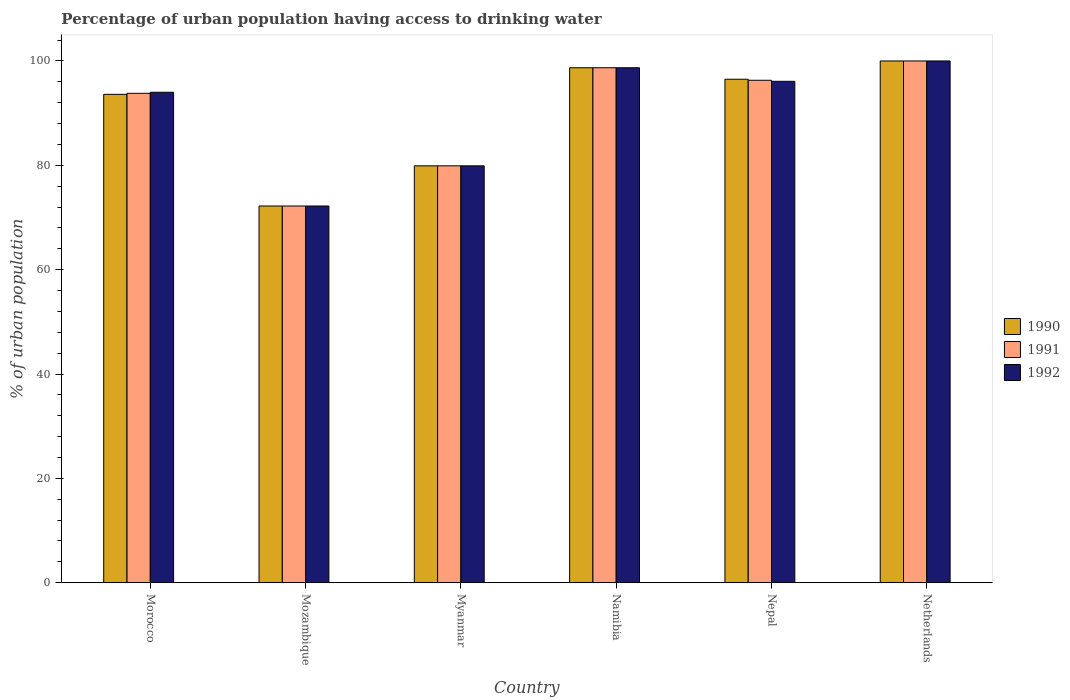How many different coloured bars are there?
Make the answer very short. 3. Are the number of bars per tick equal to the number of legend labels?
Offer a terse response. Yes. In how many cases, is the number of bars for a given country not equal to the number of legend labels?
Your response must be concise. 0. What is the percentage of urban population having access to drinking water in 1990 in Mozambique?
Provide a succinct answer. 72.2. Across all countries, what is the minimum percentage of urban population having access to drinking water in 1991?
Ensure brevity in your answer.  72.2. In which country was the percentage of urban population having access to drinking water in 1990 maximum?
Your response must be concise. Netherlands. In which country was the percentage of urban population having access to drinking water in 1991 minimum?
Give a very brief answer. Mozambique. What is the total percentage of urban population having access to drinking water in 1992 in the graph?
Your response must be concise. 540.9. What is the difference between the percentage of urban population having access to drinking water in 1990 in Myanmar and the percentage of urban population having access to drinking water in 1991 in Mozambique?
Your response must be concise. 7.7. What is the average percentage of urban population having access to drinking water in 1991 per country?
Provide a short and direct response. 90.15. What is the difference between the percentage of urban population having access to drinking water of/in 1991 and percentage of urban population having access to drinking water of/in 1990 in Namibia?
Offer a very short reply. 0. In how many countries, is the percentage of urban population having access to drinking water in 1992 greater than 48 %?
Offer a very short reply. 6. What is the ratio of the percentage of urban population having access to drinking water in 1991 in Morocco to that in Mozambique?
Provide a succinct answer. 1.3. Is the difference between the percentage of urban population having access to drinking water in 1991 in Morocco and Netherlands greater than the difference between the percentage of urban population having access to drinking water in 1990 in Morocco and Netherlands?
Provide a short and direct response. Yes. What is the difference between the highest and the second highest percentage of urban population having access to drinking water in 1990?
Offer a terse response. -2.2. What is the difference between the highest and the lowest percentage of urban population having access to drinking water in 1991?
Ensure brevity in your answer.  27.8. In how many countries, is the percentage of urban population having access to drinking water in 1991 greater than the average percentage of urban population having access to drinking water in 1991 taken over all countries?
Provide a succinct answer. 4. What does the 2nd bar from the left in Nepal represents?
Your answer should be compact. 1991. What does the 3rd bar from the right in Myanmar represents?
Offer a very short reply. 1990. Are all the bars in the graph horizontal?
Keep it short and to the point. No. How many countries are there in the graph?
Offer a very short reply. 6. What is the difference between two consecutive major ticks on the Y-axis?
Ensure brevity in your answer.  20. Where does the legend appear in the graph?
Make the answer very short. Center right. How many legend labels are there?
Offer a terse response. 3. How are the legend labels stacked?
Provide a short and direct response. Vertical. What is the title of the graph?
Provide a short and direct response. Percentage of urban population having access to drinking water. Does "1991" appear as one of the legend labels in the graph?
Give a very brief answer. Yes. What is the label or title of the X-axis?
Your answer should be compact. Country. What is the label or title of the Y-axis?
Your response must be concise. % of urban population. What is the % of urban population of 1990 in Morocco?
Provide a short and direct response. 93.6. What is the % of urban population of 1991 in Morocco?
Provide a short and direct response. 93.8. What is the % of urban population of 1992 in Morocco?
Your answer should be compact. 94. What is the % of urban population in 1990 in Mozambique?
Give a very brief answer. 72.2. What is the % of urban population in 1991 in Mozambique?
Your answer should be very brief. 72.2. What is the % of urban population of 1992 in Mozambique?
Ensure brevity in your answer.  72.2. What is the % of urban population in 1990 in Myanmar?
Give a very brief answer. 79.9. What is the % of urban population of 1991 in Myanmar?
Provide a succinct answer. 79.9. What is the % of urban population in 1992 in Myanmar?
Offer a terse response. 79.9. What is the % of urban population of 1990 in Namibia?
Your answer should be very brief. 98.7. What is the % of urban population in 1991 in Namibia?
Ensure brevity in your answer.  98.7. What is the % of urban population in 1992 in Namibia?
Keep it short and to the point. 98.7. What is the % of urban population of 1990 in Nepal?
Offer a very short reply. 96.5. What is the % of urban population in 1991 in Nepal?
Provide a succinct answer. 96.3. What is the % of urban population in 1992 in Nepal?
Ensure brevity in your answer.  96.1. What is the % of urban population in 1991 in Netherlands?
Your response must be concise. 100. What is the % of urban population in 1992 in Netherlands?
Offer a terse response. 100. Across all countries, what is the maximum % of urban population in 1991?
Your response must be concise. 100. Across all countries, what is the maximum % of urban population of 1992?
Give a very brief answer. 100. Across all countries, what is the minimum % of urban population in 1990?
Provide a succinct answer. 72.2. Across all countries, what is the minimum % of urban population in 1991?
Keep it short and to the point. 72.2. Across all countries, what is the minimum % of urban population in 1992?
Your answer should be very brief. 72.2. What is the total % of urban population of 1990 in the graph?
Provide a short and direct response. 540.9. What is the total % of urban population of 1991 in the graph?
Provide a short and direct response. 540.9. What is the total % of urban population in 1992 in the graph?
Provide a succinct answer. 540.9. What is the difference between the % of urban population in 1990 in Morocco and that in Mozambique?
Offer a very short reply. 21.4. What is the difference between the % of urban population of 1991 in Morocco and that in Mozambique?
Give a very brief answer. 21.6. What is the difference between the % of urban population of 1992 in Morocco and that in Mozambique?
Your answer should be very brief. 21.8. What is the difference between the % of urban population in 1990 in Morocco and that in Myanmar?
Provide a succinct answer. 13.7. What is the difference between the % of urban population in 1991 in Morocco and that in Myanmar?
Offer a very short reply. 13.9. What is the difference between the % of urban population of 1990 in Morocco and that in Namibia?
Ensure brevity in your answer.  -5.1. What is the difference between the % of urban population of 1992 in Morocco and that in Namibia?
Offer a terse response. -4.7. What is the difference between the % of urban population in 1990 in Morocco and that in Nepal?
Provide a succinct answer. -2.9. What is the difference between the % of urban population in 1991 in Morocco and that in Nepal?
Your answer should be very brief. -2.5. What is the difference between the % of urban population of 1992 in Morocco and that in Netherlands?
Make the answer very short. -6. What is the difference between the % of urban population in 1990 in Mozambique and that in Myanmar?
Provide a succinct answer. -7.7. What is the difference between the % of urban population in 1990 in Mozambique and that in Namibia?
Your answer should be compact. -26.5. What is the difference between the % of urban population in 1991 in Mozambique and that in Namibia?
Your response must be concise. -26.5. What is the difference between the % of urban population of 1992 in Mozambique and that in Namibia?
Provide a succinct answer. -26.5. What is the difference between the % of urban population in 1990 in Mozambique and that in Nepal?
Ensure brevity in your answer.  -24.3. What is the difference between the % of urban population of 1991 in Mozambique and that in Nepal?
Provide a succinct answer. -24.1. What is the difference between the % of urban population in 1992 in Mozambique and that in Nepal?
Keep it short and to the point. -23.9. What is the difference between the % of urban population in 1990 in Mozambique and that in Netherlands?
Your answer should be compact. -27.8. What is the difference between the % of urban population in 1991 in Mozambique and that in Netherlands?
Your answer should be very brief. -27.8. What is the difference between the % of urban population of 1992 in Mozambique and that in Netherlands?
Ensure brevity in your answer.  -27.8. What is the difference between the % of urban population of 1990 in Myanmar and that in Namibia?
Provide a short and direct response. -18.8. What is the difference between the % of urban population in 1991 in Myanmar and that in Namibia?
Make the answer very short. -18.8. What is the difference between the % of urban population in 1992 in Myanmar and that in Namibia?
Your response must be concise. -18.8. What is the difference between the % of urban population in 1990 in Myanmar and that in Nepal?
Give a very brief answer. -16.6. What is the difference between the % of urban population of 1991 in Myanmar and that in Nepal?
Your response must be concise. -16.4. What is the difference between the % of urban population in 1992 in Myanmar and that in Nepal?
Ensure brevity in your answer.  -16.2. What is the difference between the % of urban population in 1990 in Myanmar and that in Netherlands?
Offer a very short reply. -20.1. What is the difference between the % of urban population in 1991 in Myanmar and that in Netherlands?
Your answer should be very brief. -20.1. What is the difference between the % of urban population of 1992 in Myanmar and that in Netherlands?
Keep it short and to the point. -20.1. What is the difference between the % of urban population in 1990 in Namibia and that in Nepal?
Offer a very short reply. 2.2. What is the difference between the % of urban population in 1991 in Namibia and that in Nepal?
Provide a short and direct response. 2.4. What is the difference between the % of urban population of 1992 in Namibia and that in Nepal?
Your answer should be compact. 2.6. What is the difference between the % of urban population of 1992 in Namibia and that in Netherlands?
Your answer should be very brief. -1.3. What is the difference between the % of urban population in 1990 in Nepal and that in Netherlands?
Offer a terse response. -3.5. What is the difference between the % of urban population in 1991 in Nepal and that in Netherlands?
Keep it short and to the point. -3.7. What is the difference between the % of urban population of 1992 in Nepal and that in Netherlands?
Make the answer very short. -3.9. What is the difference between the % of urban population of 1990 in Morocco and the % of urban population of 1991 in Mozambique?
Your response must be concise. 21.4. What is the difference between the % of urban population in 1990 in Morocco and the % of urban population in 1992 in Mozambique?
Your answer should be very brief. 21.4. What is the difference between the % of urban population of 1991 in Morocco and the % of urban population of 1992 in Mozambique?
Offer a very short reply. 21.6. What is the difference between the % of urban population in 1991 in Morocco and the % of urban population in 1992 in Myanmar?
Your answer should be very brief. 13.9. What is the difference between the % of urban population of 1991 in Morocco and the % of urban population of 1992 in Namibia?
Make the answer very short. -4.9. What is the difference between the % of urban population in 1990 in Morocco and the % of urban population in 1992 in Nepal?
Make the answer very short. -2.5. What is the difference between the % of urban population in 1991 in Morocco and the % of urban population in 1992 in Netherlands?
Make the answer very short. -6.2. What is the difference between the % of urban population of 1990 in Mozambique and the % of urban population of 1991 in Namibia?
Offer a very short reply. -26.5. What is the difference between the % of urban population of 1990 in Mozambique and the % of urban population of 1992 in Namibia?
Keep it short and to the point. -26.5. What is the difference between the % of urban population of 1991 in Mozambique and the % of urban population of 1992 in Namibia?
Your answer should be very brief. -26.5. What is the difference between the % of urban population of 1990 in Mozambique and the % of urban population of 1991 in Nepal?
Keep it short and to the point. -24.1. What is the difference between the % of urban population of 1990 in Mozambique and the % of urban population of 1992 in Nepal?
Your response must be concise. -23.9. What is the difference between the % of urban population of 1991 in Mozambique and the % of urban population of 1992 in Nepal?
Your answer should be very brief. -23.9. What is the difference between the % of urban population of 1990 in Mozambique and the % of urban population of 1991 in Netherlands?
Give a very brief answer. -27.8. What is the difference between the % of urban population in 1990 in Mozambique and the % of urban population in 1992 in Netherlands?
Provide a succinct answer. -27.8. What is the difference between the % of urban population in 1991 in Mozambique and the % of urban population in 1992 in Netherlands?
Provide a succinct answer. -27.8. What is the difference between the % of urban population of 1990 in Myanmar and the % of urban population of 1991 in Namibia?
Your response must be concise. -18.8. What is the difference between the % of urban population of 1990 in Myanmar and the % of urban population of 1992 in Namibia?
Your answer should be very brief. -18.8. What is the difference between the % of urban population in 1991 in Myanmar and the % of urban population in 1992 in Namibia?
Provide a succinct answer. -18.8. What is the difference between the % of urban population in 1990 in Myanmar and the % of urban population in 1991 in Nepal?
Give a very brief answer. -16.4. What is the difference between the % of urban population in 1990 in Myanmar and the % of urban population in 1992 in Nepal?
Provide a succinct answer. -16.2. What is the difference between the % of urban population of 1991 in Myanmar and the % of urban population of 1992 in Nepal?
Your answer should be very brief. -16.2. What is the difference between the % of urban population in 1990 in Myanmar and the % of urban population in 1991 in Netherlands?
Make the answer very short. -20.1. What is the difference between the % of urban population in 1990 in Myanmar and the % of urban population in 1992 in Netherlands?
Your answer should be compact. -20.1. What is the difference between the % of urban population of 1991 in Myanmar and the % of urban population of 1992 in Netherlands?
Your answer should be very brief. -20.1. What is the difference between the % of urban population in 1990 in Namibia and the % of urban population in 1991 in Nepal?
Your answer should be very brief. 2.4. What is the difference between the % of urban population in 1991 in Namibia and the % of urban population in 1992 in Netherlands?
Give a very brief answer. -1.3. What is the difference between the % of urban population in 1990 in Nepal and the % of urban population in 1992 in Netherlands?
Provide a short and direct response. -3.5. What is the average % of urban population in 1990 per country?
Provide a short and direct response. 90.15. What is the average % of urban population of 1991 per country?
Keep it short and to the point. 90.15. What is the average % of urban population of 1992 per country?
Keep it short and to the point. 90.15. What is the difference between the % of urban population in 1990 and % of urban population in 1991 in Morocco?
Provide a succinct answer. -0.2. What is the difference between the % of urban population of 1990 and % of urban population of 1992 in Morocco?
Your response must be concise. -0.4. What is the difference between the % of urban population of 1990 and % of urban population of 1992 in Myanmar?
Make the answer very short. 0. What is the difference between the % of urban population of 1991 and % of urban population of 1992 in Namibia?
Your answer should be compact. 0. What is the difference between the % of urban population of 1990 and % of urban population of 1992 in Nepal?
Give a very brief answer. 0.4. What is the difference between the % of urban population in 1990 and % of urban population in 1991 in Netherlands?
Ensure brevity in your answer.  0. What is the difference between the % of urban population in 1991 and % of urban population in 1992 in Netherlands?
Ensure brevity in your answer.  0. What is the ratio of the % of urban population in 1990 in Morocco to that in Mozambique?
Provide a short and direct response. 1.3. What is the ratio of the % of urban population of 1991 in Morocco to that in Mozambique?
Your answer should be compact. 1.3. What is the ratio of the % of urban population in 1992 in Morocco to that in Mozambique?
Offer a terse response. 1.3. What is the ratio of the % of urban population in 1990 in Morocco to that in Myanmar?
Provide a succinct answer. 1.17. What is the ratio of the % of urban population of 1991 in Morocco to that in Myanmar?
Make the answer very short. 1.17. What is the ratio of the % of urban population in 1992 in Morocco to that in Myanmar?
Your answer should be compact. 1.18. What is the ratio of the % of urban population in 1990 in Morocco to that in Namibia?
Offer a very short reply. 0.95. What is the ratio of the % of urban population of 1991 in Morocco to that in Namibia?
Your answer should be very brief. 0.95. What is the ratio of the % of urban population of 1990 in Morocco to that in Nepal?
Offer a terse response. 0.97. What is the ratio of the % of urban population in 1992 in Morocco to that in Nepal?
Your response must be concise. 0.98. What is the ratio of the % of urban population of 1990 in Morocco to that in Netherlands?
Ensure brevity in your answer.  0.94. What is the ratio of the % of urban population in 1991 in Morocco to that in Netherlands?
Your answer should be very brief. 0.94. What is the ratio of the % of urban population in 1992 in Morocco to that in Netherlands?
Offer a terse response. 0.94. What is the ratio of the % of urban population in 1990 in Mozambique to that in Myanmar?
Ensure brevity in your answer.  0.9. What is the ratio of the % of urban population of 1991 in Mozambique to that in Myanmar?
Your answer should be very brief. 0.9. What is the ratio of the % of urban population in 1992 in Mozambique to that in Myanmar?
Your response must be concise. 0.9. What is the ratio of the % of urban population in 1990 in Mozambique to that in Namibia?
Your answer should be very brief. 0.73. What is the ratio of the % of urban population in 1991 in Mozambique to that in Namibia?
Ensure brevity in your answer.  0.73. What is the ratio of the % of urban population in 1992 in Mozambique to that in Namibia?
Your answer should be very brief. 0.73. What is the ratio of the % of urban population of 1990 in Mozambique to that in Nepal?
Your response must be concise. 0.75. What is the ratio of the % of urban population in 1991 in Mozambique to that in Nepal?
Provide a succinct answer. 0.75. What is the ratio of the % of urban population of 1992 in Mozambique to that in Nepal?
Give a very brief answer. 0.75. What is the ratio of the % of urban population of 1990 in Mozambique to that in Netherlands?
Ensure brevity in your answer.  0.72. What is the ratio of the % of urban population of 1991 in Mozambique to that in Netherlands?
Make the answer very short. 0.72. What is the ratio of the % of urban population of 1992 in Mozambique to that in Netherlands?
Keep it short and to the point. 0.72. What is the ratio of the % of urban population in 1990 in Myanmar to that in Namibia?
Your answer should be compact. 0.81. What is the ratio of the % of urban population of 1991 in Myanmar to that in Namibia?
Your answer should be very brief. 0.81. What is the ratio of the % of urban population in 1992 in Myanmar to that in Namibia?
Your answer should be very brief. 0.81. What is the ratio of the % of urban population of 1990 in Myanmar to that in Nepal?
Offer a very short reply. 0.83. What is the ratio of the % of urban population of 1991 in Myanmar to that in Nepal?
Your answer should be compact. 0.83. What is the ratio of the % of urban population of 1992 in Myanmar to that in Nepal?
Offer a very short reply. 0.83. What is the ratio of the % of urban population in 1990 in Myanmar to that in Netherlands?
Offer a terse response. 0.8. What is the ratio of the % of urban population in 1991 in Myanmar to that in Netherlands?
Offer a very short reply. 0.8. What is the ratio of the % of urban population of 1992 in Myanmar to that in Netherlands?
Your answer should be compact. 0.8. What is the ratio of the % of urban population in 1990 in Namibia to that in Nepal?
Give a very brief answer. 1.02. What is the ratio of the % of urban population in 1991 in Namibia to that in Nepal?
Your response must be concise. 1.02. What is the ratio of the % of urban population in 1992 in Namibia to that in Nepal?
Your answer should be compact. 1.03. What is the ratio of the % of urban population in 1991 in Namibia to that in Netherlands?
Offer a terse response. 0.99. What is the ratio of the % of urban population of 1992 in Namibia to that in Netherlands?
Keep it short and to the point. 0.99. What is the ratio of the % of urban population of 1990 in Nepal to that in Netherlands?
Provide a short and direct response. 0.96. What is the ratio of the % of urban population in 1992 in Nepal to that in Netherlands?
Make the answer very short. 0.96. What is the difference between the highest and the second highest % of urban population of 1990?
Make the answer very short. 1.3. What is the difference between the highest and the second highest % of urban population in 1991?
Keep it short and to the point. 1.3. What is the difference between the highest and the second highest % of urban population of 1992?
Provide a short and direct response. 1.3. What is the difference between the highest and the lowest % of urban population in 1990?
Your response must be concise. 27.8. What is the difference between the highest and the lowest % of urban population in 1991?
Make the answer very short. 27.8. What is the difference between the highest and the lowest % of urban population in 1992?
Offer a very short reply. 27.8. 